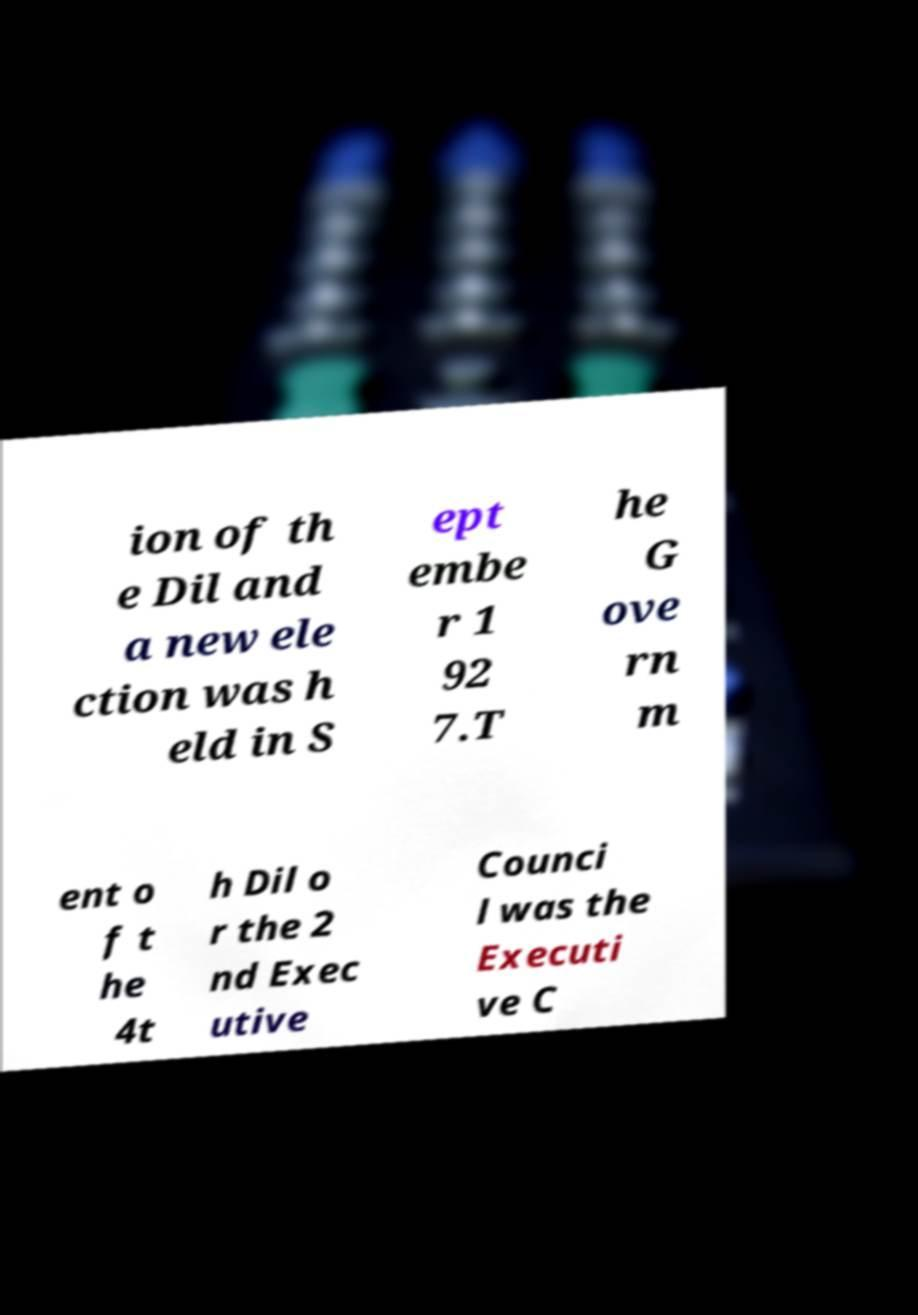I need the written content from this picture converted into text. Can you do that? ion of th e Dil and a new ele ction was h eld in S ept embe r 1 92 7.T he G ove rn m ent o f t he 4t h Dil o r the 2 nd Exec utive Counci l was the Executi ve C 